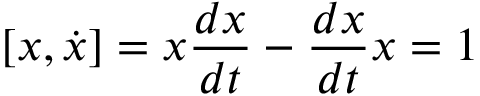Convert formula to latex. <formula><loc_0><loc_0><loc_500><loc_500>[ x , { \dot { x } } ] = x { \frac { d x } { d t } } - { \frac { d x } { d t } } x = 1</formula> 